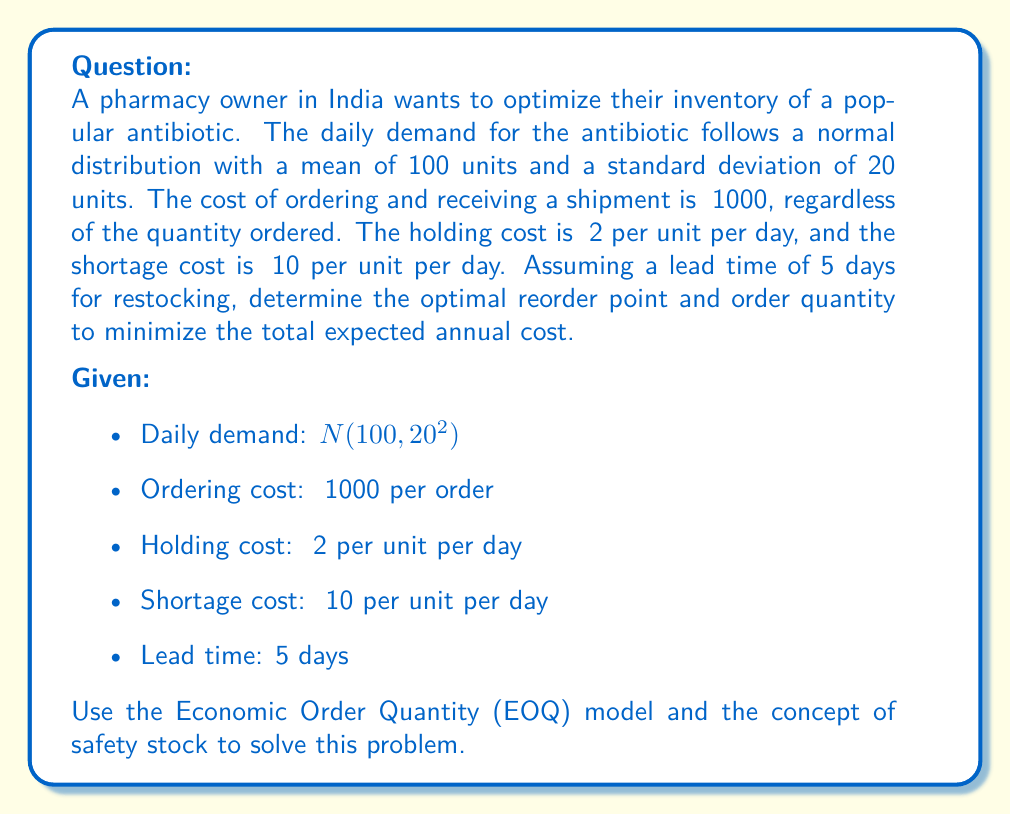Can you solve this math problem? To solve this problem, we'll follow these steps:

1. Calculate the Economic Order Quantity (EOQ)
2. Determine the safety stock
3. Calculate the reorder point
4. Compute the total expected annual cost

Step 1: Calculate the EOQ

The EOQ formula is:

$$ Q = \sqrt{\frac{2DS}{H}} $$

Where:
$Q$ = Economic Order Quantity
$D$ = Annual demand = 100 units/day × 365 days = 36,500 units
$S$ = Ordering cost = ₹1000
$H$ = Annual holding cost per unit = ₹2 × 365 days = ₹730

$$ Q = \sqrt{\frac{2 \times 36,500 \times 1000}{730}} \approx 316 \text{ units} $$

Step 2: Determine the safety stock

For a 95% service level (z-score = 1.645), the safety stock is:

$$ SS = z \times \sigma \times \sqrt{L} $$

Where:
$z$ = 1.645 (95% service level)
$\sigma$ = Standard deviation of daily demand = 20 units
$L$ = Lead time = 5 days

$$ SS = 1.645 \times 20 \times \sqrt{5} \approx 74 \text{ units} $$

Step 3: Calculate the reorder point

$$ ROP = (\text{Average daily demand} \times \text{Lead time}) + SS $$
$$ ROP = (100 \times 5) + 74 = 574 \text{ units} $$

Step 4: Compute the total expected annual cost

Annual ordering cost: $\frac{D}{Q} \times S = \frac{36,500}{316} \times 1000 \approx ₹115,506$

Annual holding cost: $\frac{Q}{2} \times H + SS \times H = \frac{316}{2} \times 730 + 74 \times 730 \approx ₹169,724$

Annual shortage cost (approximation):
$$ \text{Annual shortage cost} \approx \frac{D}{Q} \times p \times E(M) $$

Where:
$p$ = Shortage cost per unit = ₹10
$E(M)$ = Expected shortage per cycle ≈ $\frac{\sigma_L \times f(z)}{1-G(z)}$
$\sigma_L$ = Standard deviation of demand during lead time = $20 \times \sqrt{5} \approx 44.72$
$f(z)$ and $G(z)$ are the standard normal density and cumulative distribution functions

$E(M) \approx \frac{44.72 \times 0.103}{0.05} \approx 92$ units

Annual shortage cost $\approx \frac{36,500}{316} \times 10 \times 92 \approx ₹106,266$

Total expected annual cost = ₹115,506 + ₹169,724 + ₹106,266 = ₹391,496
Answer: The optimal reorder point is 574 units, and the optimal order quantity is 316 units. The total expected annual cost with this inventory policy is approximately ₹391,496. 